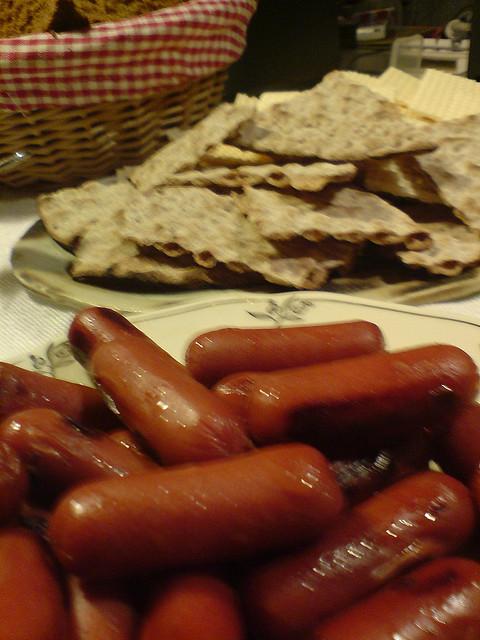What food is in the foreground of the picture?
Keep it brief. Sausage. Are the hot dogs delicious?
Be succinct. Yes. Does the food in front have skin?
Keep it brief. Yes. Is this vegetarian?
Be succinct. No. Are any of the hot dogs cooked more than others?
Give a very brief answer. Yes. 